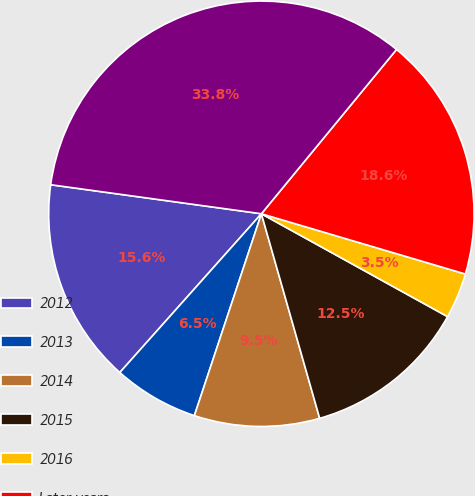Convert chart to OTSL. <chart><loc_0><loc_0><loc_500><loc_500><pie_chart><fcel>2012<fcel>2013<fcel>2014<fcel>2015<fcel>2016<fcel>Later years<fcel>Total minimum lease payments<nl><fcel>15.59%<fcel>6.49%<fcel>9.52%<fcel>12.55%<fcel>3.46%<fcel>18.62%<fcel>33.78%<nl></chart> 